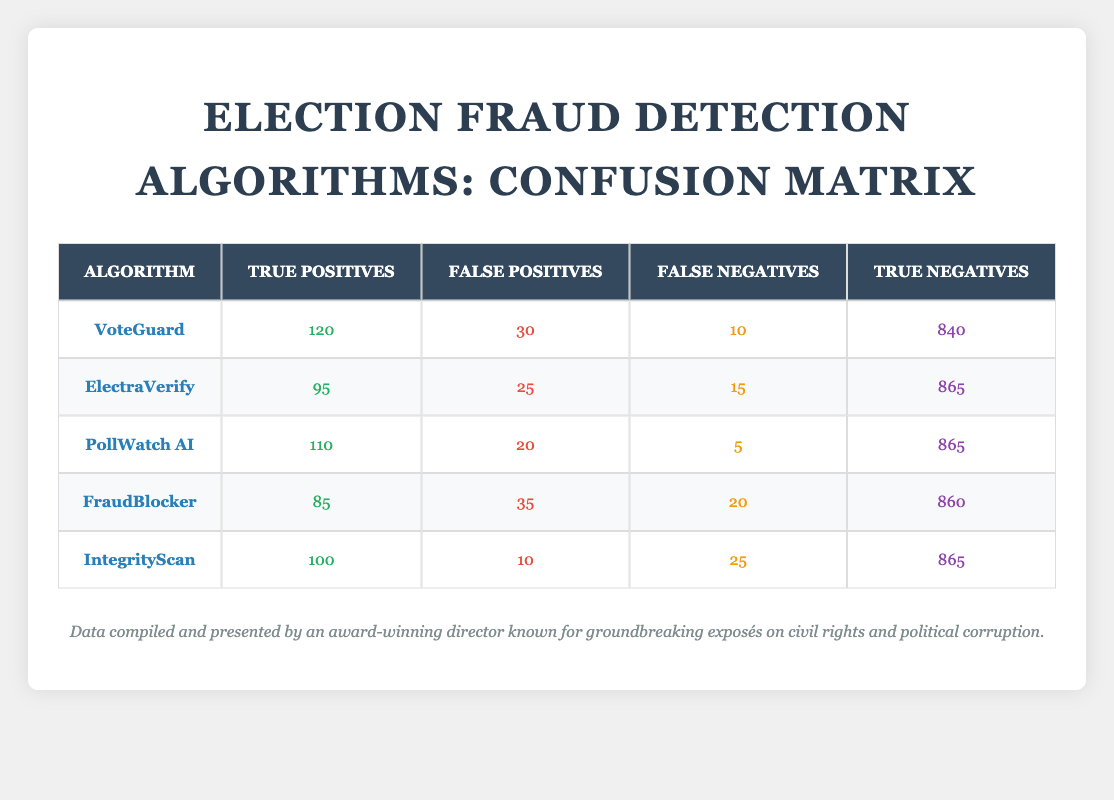What is the total number of true positives across all algorithms? To find the total number of true positives, we add the true positives from each algorithm: 120 (VoteGuard) + 95 (ElectraVerify) + 110 (PollWatch AI) + 85 (FraudBlocker) + 100 (IntegrityScan) = 510.
Answer: 510 Which algorithm has the highest number of false positives? By comparing the false positives of each algorithm, we see that VoteGuard has 30, ElectraVerify has 25, PollWatch AI has 20, FraudBlocker has 35, and IntegrityScan has 10. The highest is 35 from FraudBlocker.
Answer: FraudBlocker Are there any algorithms that have the same number of true negatives? Looking at the true negatives for each algorithm, we identify that both PollWatch AI and IntegrityScan have 865 true negatives. Therefore, they have the same number.
Answer: Yes What is the average number of false negatives for all algorithms? To calculate the average, we first sum the false negatives: 10 (VoteGuard) + 15 (ElectraVerify) + 5 (PollWatch AI) + 20 (FraudBlocker) + 25 (IntegrityScan) = 75. Then divide by the number of algorithms, which is 5, giving us an average of 75 / 5 = 15.
Answer: 15 Which algorithm has the best overall performance based on true positives and false negatives? Evaluating the performance involves weighing true positives against false negatives. PollWatch AI has a high true positive of 110 and the lowest false negatives at 5, making it likely the best performer in terms of correctness and reliability.
Answer: PollWatch AI 